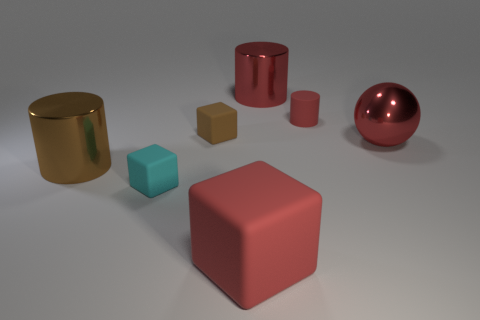Subtract all small cubes. How many cubes are left? 1 Add 1 large red things. How many objects exist? 8 Subtract all cubes. How many objects are left? 4 Subtract all green cubes. How many purple spheres are left? 0 Add 4 big objects. How many big objects exist? 8 Subtract all cyan blocks. How many blocks are left? 2 Subtract 0 purple spheres. How many objects are left? 7 Subtract 2 blocks. How many blocks are left? 1 Subtract all purple cylinders. Subtract all cyan blocks. How many cylinders are left? 3 Subtract all big gray objects. Subtract all tiny matte cylinders. How many objects are left? 6 